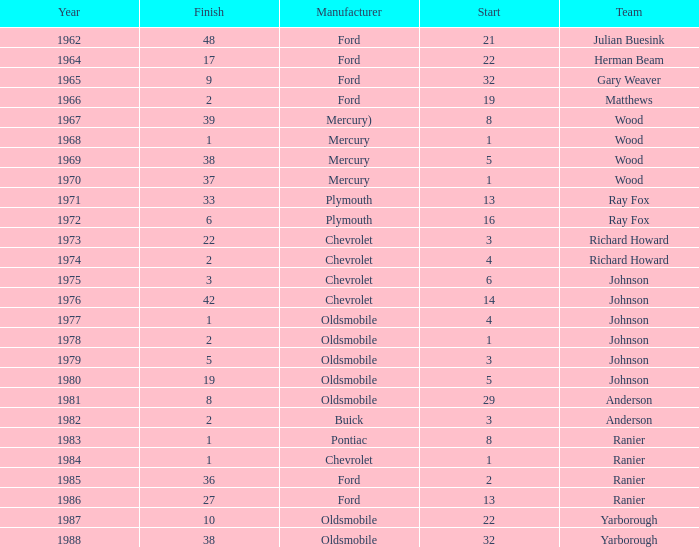What is the smallest finish time for a race where start was less than 3, buick was the manufacturer, and the race was held after 1978? None. 